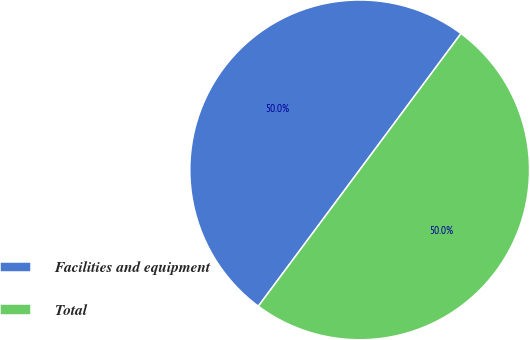<chart> <loc_0><loc_0><loc_500><loc_500><pie_chart><fcel>Facilities and equipment<fcel>Total<nl><fcel>50.0%<fcel>50.0%<nl></chart> 